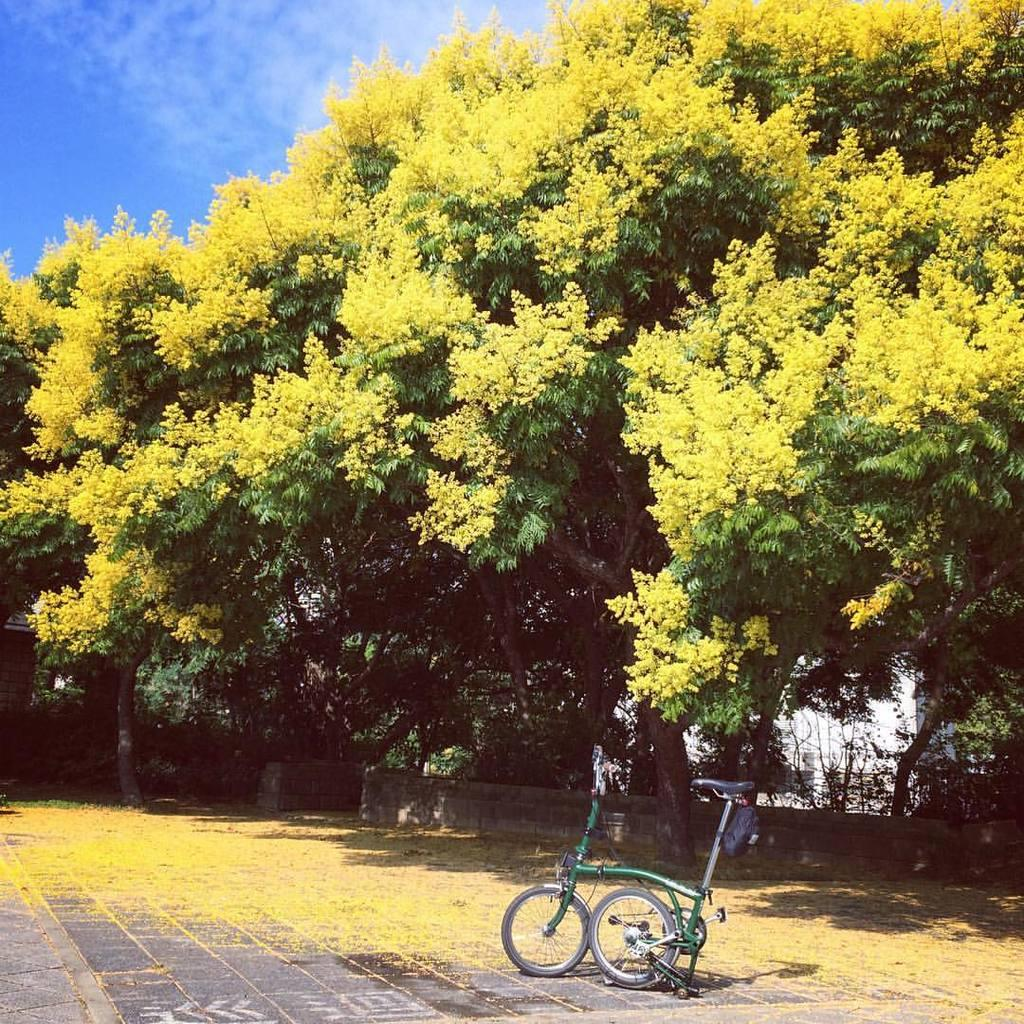What type of surface is the path made of in the image? The path surface in the image is made of tiles. What can be seen growing on the path in the image? There is a tree with flowers on the path surface in the image. Where is the tree located in relation to the path? The tree is on the path surface in the image. What is visible in the background of the image? The sky is visible in the image, and clouds are present in the sky. Can you tell me how many cushions are on the path in the image? There are no cushions present in the image; it features a path surface with tiles and a tree with flowers. Is there a ghost visible in the image? There is no ghost present in the image. 